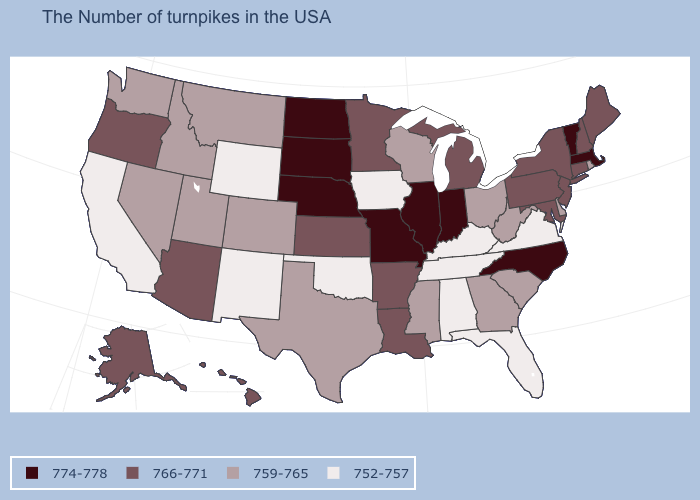What is the value of South Carolina?
Short answer required. 759-765. What is the value of Colorado?
Quick response, please. 759-765. Name the states that have a value in the range 759-765?
Be succinct. Rhode Island, Delaware, South Carolina, West Virginia, Ohio, Georgia, Wisconsin, Mississippi, Texas, Colorado, Utah, Montana, Idaho, Nevada, Washington. What is the value of Idaho?
Be succinct. 759-765. Among the states that border Connecticut , does Rhode Island have the lowest value?
Give a very brief answer. Yes. Does Indiana have the highest value in the USA?
Quick response, please. Yes. How many symbols are there in the legend?
Concise answer only. 4. Which states have the lowest value in the MidWest?
Keep it brief. Iowa. Does Maryland have a lower value than Illinois?
Quick response, please. Yes. Among the states that border Wisconsin , does Michigan have the lowest value?
Keep it brief. No. Which states hav the highest value in the West?
Quick response, please. Arizona, Oregon, Alaska, Hawaii. Name the states that have a value in the range 774-778?
Quick response, please. Massachusetts, Vermont, North Carolina, Indiana, Illinois, Missouri, Nebraska, South Dakota, North Dakota. Name the states that have a value in the range 752-757?
Be succinct. Virginia, Florida, Kentucky, Alabama, Tennessee, Iowa, Oklahoma, Wyoming, New Mexico, California. What is the value of Tennessee?
Be succinct. 752-757. What is the highest value in the USA?
Write a very short answer. 774-778. 